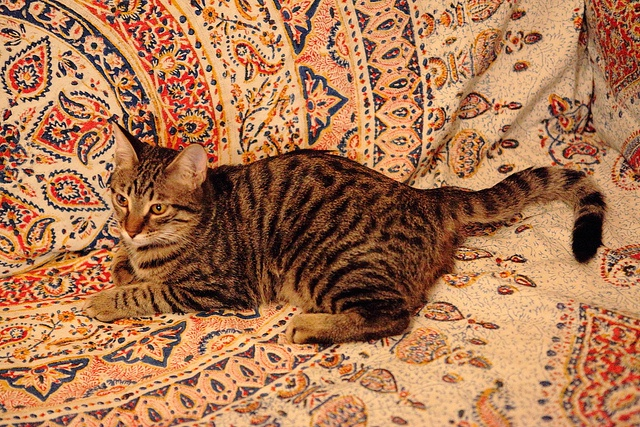Describe the objects in this image and their specific colors. I can see couch in black, tan, and gray tones and cat in black, maroon, and brown tones in this image. 